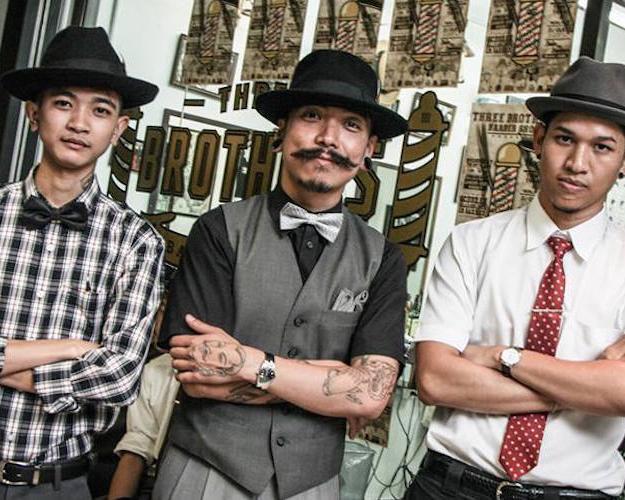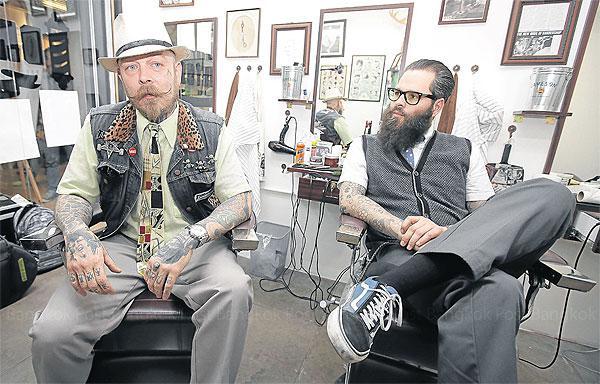The first image is the image on the left, the second image is the image on the right. Assess this claim about the two images: "One image shows three forward-facing men, and the man in the middle has a mustache and wears a vest.". Correct or not? Answer yes or no. Yes. 